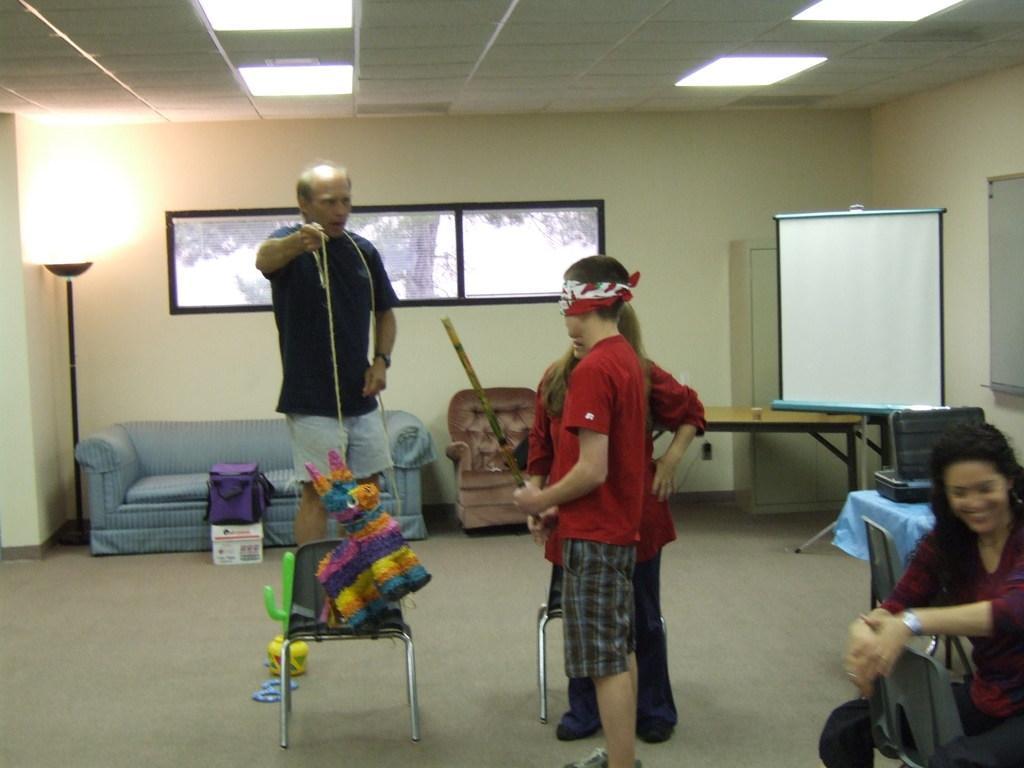Can you describe this image briefly? In the image we can see there are four person and two chair. There is sofa, light lamp and a whiteboard. 